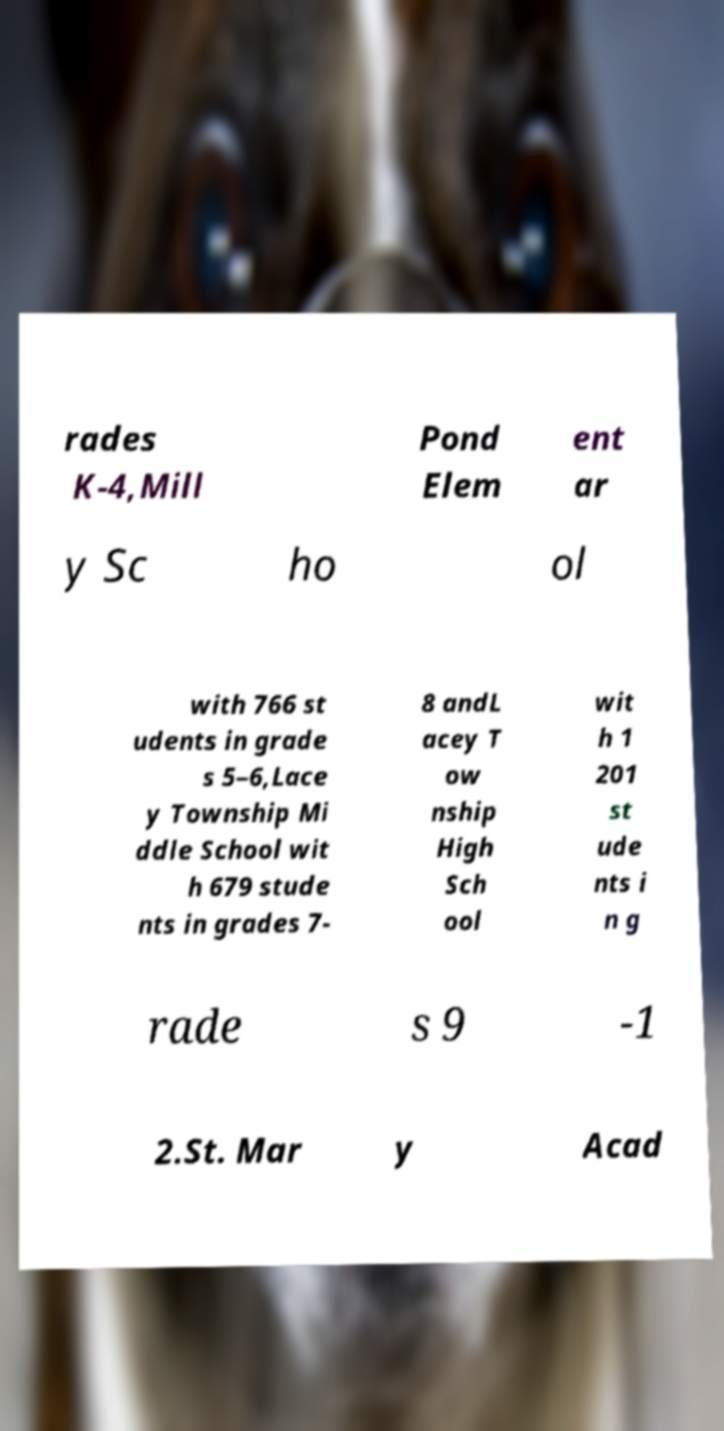There's text embedded in this image that I need extracted. Can you transcribe it verbatim? rades K-4,Mill Pond Elem ent ar y Sc ho ol with 766 st udents in grade s 5–6,Lace y Township Mi ddle School wit h 679 stude nts in grades 7- 8 andL acey T ow nship High Sch ool wit h 1 201 st ude nts i n g rade s 9 -1 2.St. Mar y Acad 